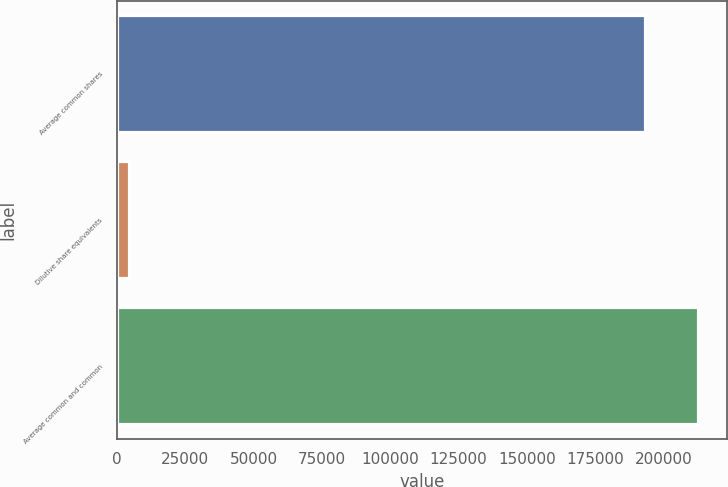Convert chart. <chart><loc_0><loc_0><loc_500><loc_500><bar_chart><fcel>Average common shares<fcel>Dilutive share equivalents<fcel>Average common and common<nl><fcel>193299<fcel>4410<fcel>212629<nl></chart> 